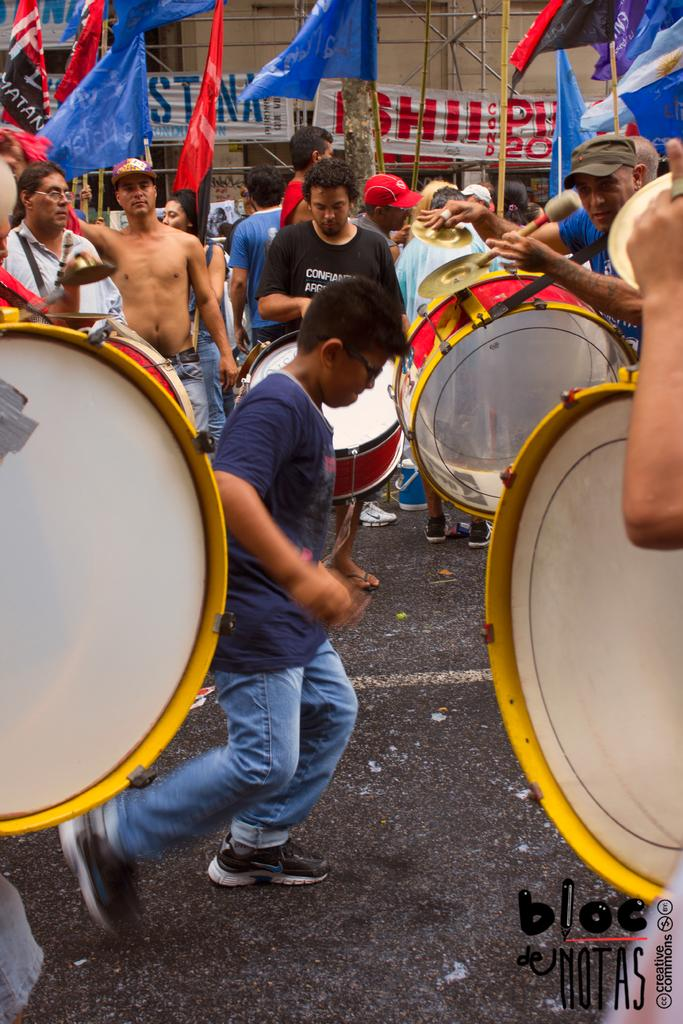What is happening in the image? There are people in the image, and some of them are playing musical instruments. Can you describe the background of the image? In the background of the image, there are flags. How many rabbits can be seen in the image? There are no rabbits present in the image. What type of business is being conducted in the image? The image does not depict any business activities. 